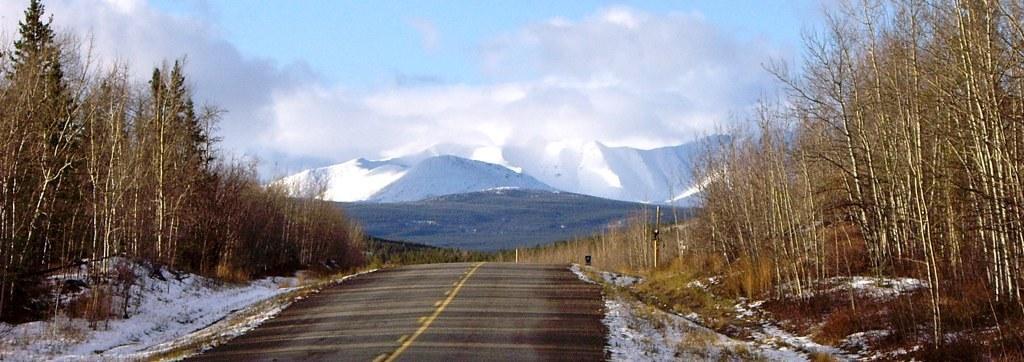Can you describe this image briefly? In the center of a picture it is road. On the right there are trees, shrubs, grass, pole and snow. On the left there are trees, plants and snow. In the center of the background there are mountains covered with snow and trees. At the top there are clouds. 